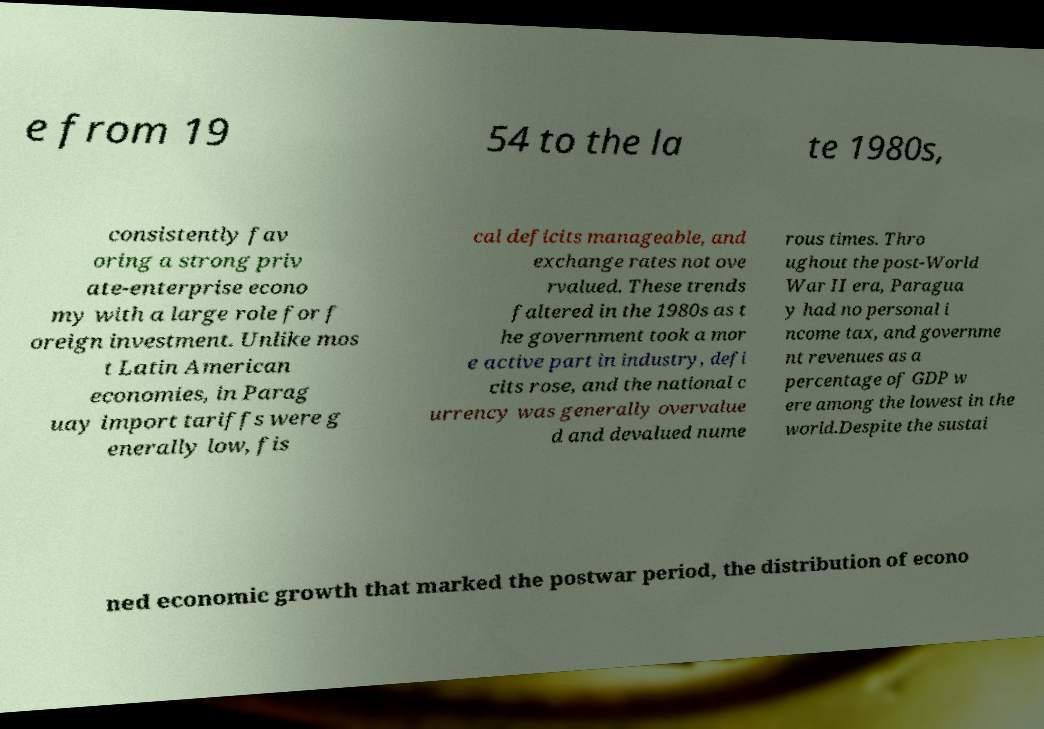I need the written content from this picture converted into text. Can you do that? e from 19 54 to the la te 1980s, consistently fav oring a strong priv ate-enterprise econo my with a large role for f oreign investment. Unlike mos t Latin American economies, in Parag uay import tariffs were g enerally low, fis cal deficits manageable, and exchange rates not ove rvalued. These trends faltered in the 1980s as t he government took a mor e active part in industry, defi cits rose, and the national c urrency was generally overvalue d and devalued nume rous times. Thro ughout the post-World War II era, Paragua y had no personal i ncome tax, and governme nt revenues as a percentage of GDP w ere among the lowest in the world.Despite the sustai ned economic growth that marked the postwar period, the distribution of econo 